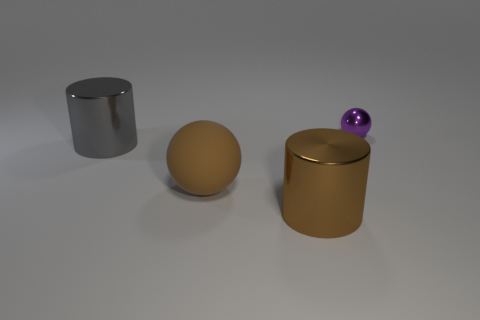Is there anything else that is the same size as the purple sphere?
Your answer should be very brief. No. Are there more tiny purple metal objects that are behind the big brown rubber object than large shiny cylinders that are right of the brown metal thing?
Offer a terse response. Yes. What number of other things are there of the same size as the gray cylinder?
Your answer should be compact. 2. What is the material of the object that is on the left side of the big brown shiny object and in front of the gray metallic object?
Your answer should be compact. Rubber. There is another thing that is the same shape as the small purple object; what material is it?
Make the answer very short. Rubber. How many cylinders are in front of the tiny thing behind the large metallic object in front of the big sphere?
Your answer should be very brief. 2. Is there anything else of the same color as the tiny thing?
Ensure brevity in your answer.  No. What number of things are right of the large ball and behind the brown metallic object?
Provide a short and direct response. 1. There is a brown object on the left side of the large brown cylinder; is its size the same as the metal cylinder in front of the gray object?
Your answer should be compact. Yes. What number of objects are either big brown cylinders that are in front of the small purple object or small red metallic objects?
Ensure brevity in your answer.  1. 